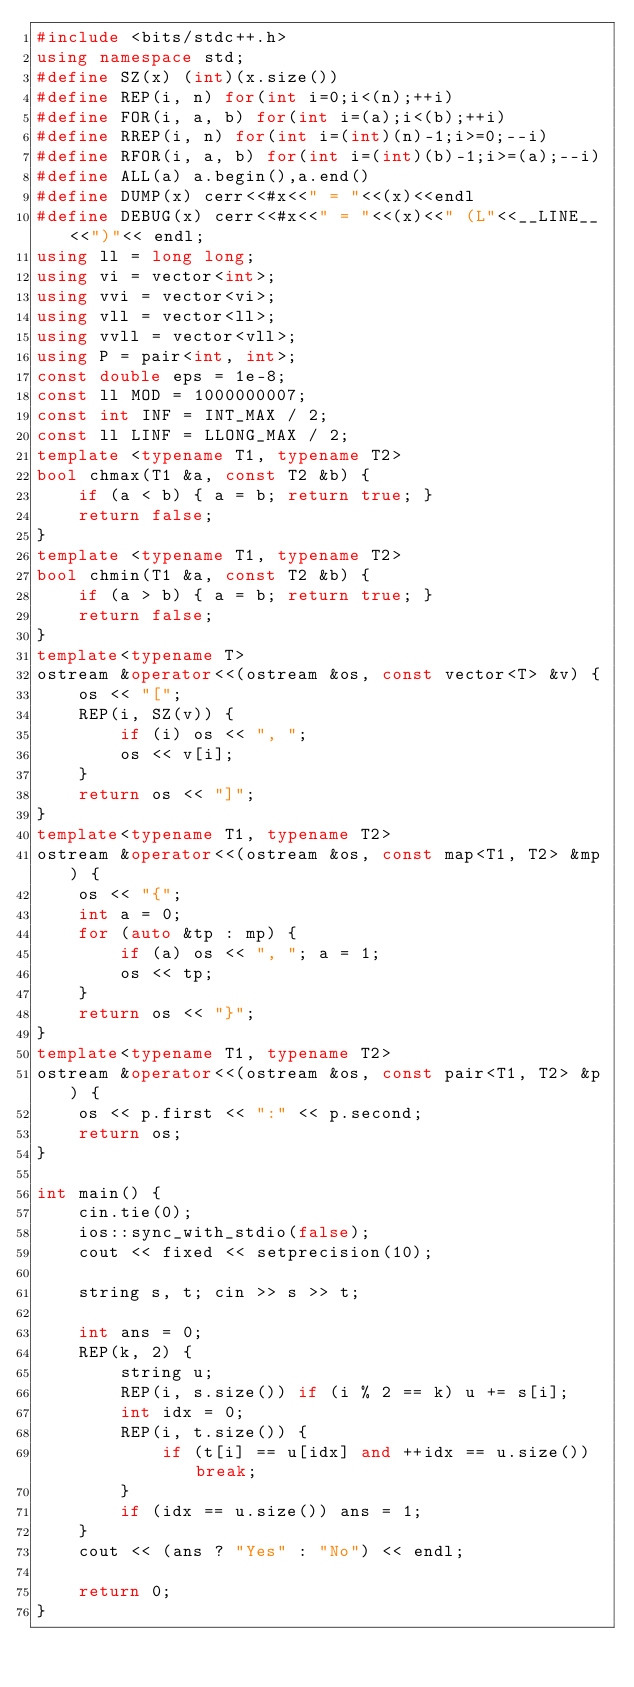<code> <loc_0><loc_0><loc_500><loc_500><_C++_>#include <bits/stdc++.h>
using namespace std;
#define SZ(x) (int)(x.size())
#define REP(i, n) for(int i=0;i<(n);++i)
#define FOR(i, a, b) for(int i=(a);i<(b);++i)
#define RREP(i, n) for(int i=(int)(n)-1;i>=0;--i)
#define RFOR(i, a, b) for(int i=(int)(b)-1;i>=(a);--i)
#define ALL(a) a.begin(),a.end()
#define DUMP(x) cerr<<#x<<" = "<<(x)<<endl
#define DEBUG(x) cerr<<#x<<" = "<<(x)<<" (L"<<__LINE__<<")"<< endl;
using ll = long long;
using vi = vector<int>;
using vvi = vector<vi>;
using vll = vector<ll>;
using vvll = vector<vll>;
using P = pair<int, int>;
const double eps = 1e-8;
const ll MOD = 1000000007;
const int INF = INT_MAX / 2;
const ll LINF = LLONG_MAX / 2;
template <typename T1, typename T2>
bool chmax(T1 &a, const T2 &b) {
    if (a < b) { a = b; return true; }
    return false;
}
template <typename T1, typename T2>
bool chmin(T1 &a, const T2 &b) {
    if (a > b) { a = b; return true; }
    return false;
}
template<typename T>
ostream &operator<<(ostream &os, const vector<T> &v) {
    os << "[";
    REP(i, SZ(v)) {
        if (i) os << ", ";
        os << v[i];
    }
    return os << "]";
}
template<typename T1, typename T2>
ostream &operator<<(ostream &os, const map<T1, T2> &mp) {
    os << "{";
    int a = 0;
    for (auto &tp : mp) {
        if (a) os << ", "; a = 1;
        os << tp;
    }
    return os << "}";
}
template<typename T1, typename T2>
ostream &operator<<(ostream &os, const pair<T1, T2> &p) {
    os << p.first << ":" << p.second;
    return os;
}

int main() {
    cin.tie(0);
    ios::sync_with_stdio(false);
    cout << fixed << setprecision(10);

    string s, t; cin >> s >> t;

    int ans = 0;
    REP(k, 2) {
        string u;
        REP(i, s.size()) if (i % 2 == k) u += s[i];
        int idx = 0;
        REP(i, t.size()) {
            if (t[i] == u[idx] and ++idx == u.size()) break;
        }
        if (idx == u.size()) ans = 1;
    }
    cout << (ans ? "Yes" : "No") << endl;

    return 0;
}

</code> 